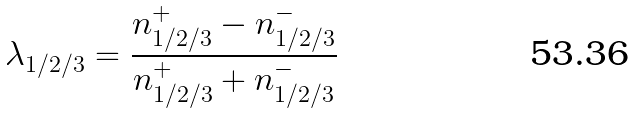<formula> <loc_0><loc_0><loc_500><loc_500>\lambda _ { 1 / 2 / 3 } = \frac { n _ { 1 / 2 / 3 } ^ { + } - n _ { 1 / 2 / 3 } ^ { - } } { n _ { 1 / 2 / 3 } ^ { + } + n _ { 1 / 2 / 3 } ^ { - } }</formula> 